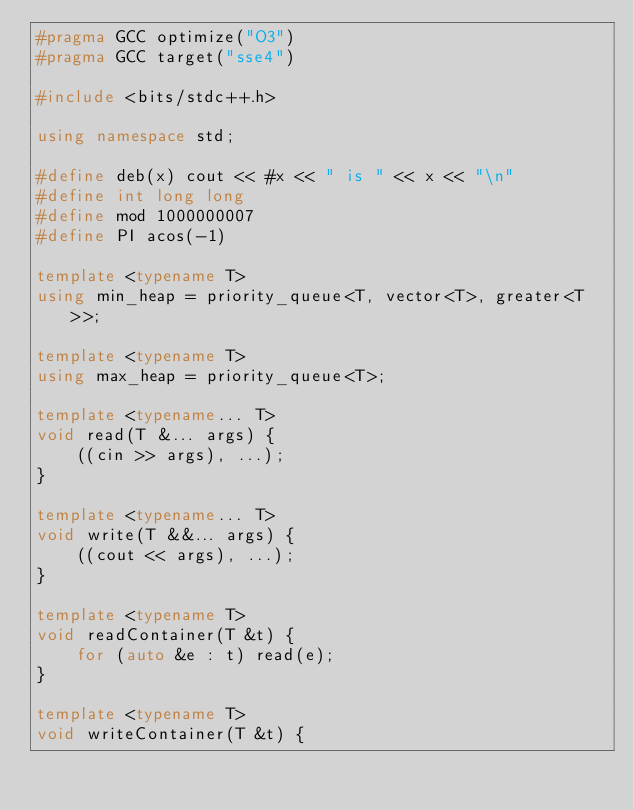<code> <loc_0><loc_0><loc_500><loc_500><_C++_>#pragma GCC optimize("O3")
#pragma GCC target("sse4")

#include <bits/stdc++.h>

using namespace std;

#define deb(x) cout << #x << " is " << x << "\n"
#define int long long
#define mod 1000000007
#define PI acos(-1)

template <typename T>
using min_heap = priority_queue<T, vector<T>, greater<T>>;

template <typename T>
using max_heap = priority_queue<T>;

template <typename... T>
void read(T &... args) {
    ((cin >> args), ...);
}

template <typename... T>
void write(T &&... args) {
    ((cout << args), ...);
}

template <typename T>
void readContainer(T &t) {
    for (auto &e : t) read(e);
}

template <typename T>
void writeContainer(T &t) {</code> 